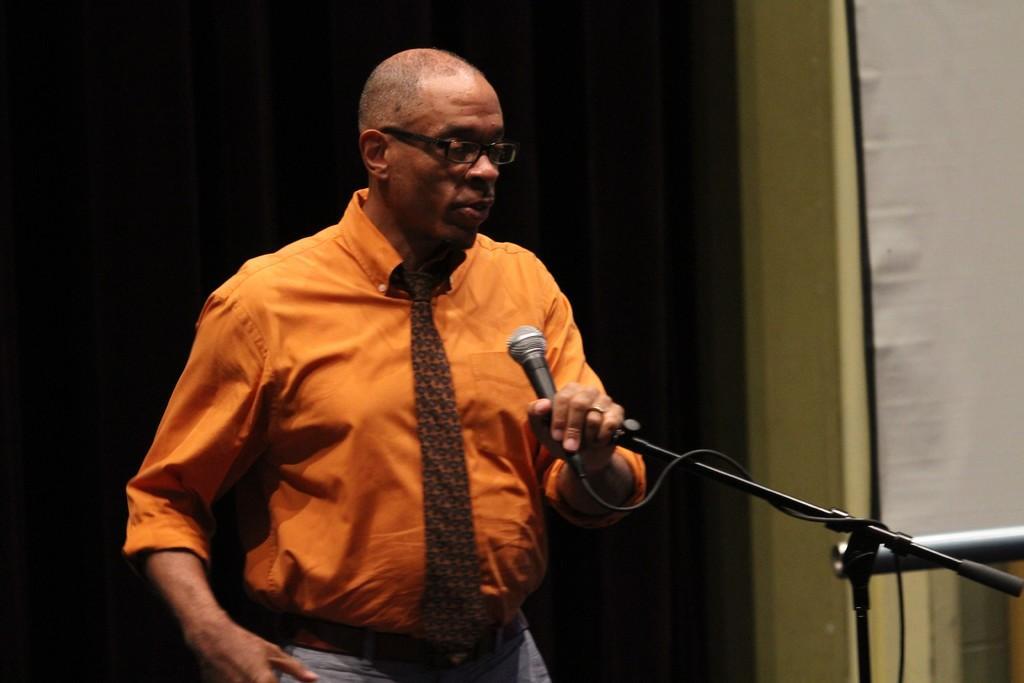Please provide a concise description of this image. A person wearing a orange shirt and tie also wearing a spectacles is holding a mic. And a mic stand is in front of him. In the background there is a black curtain. 